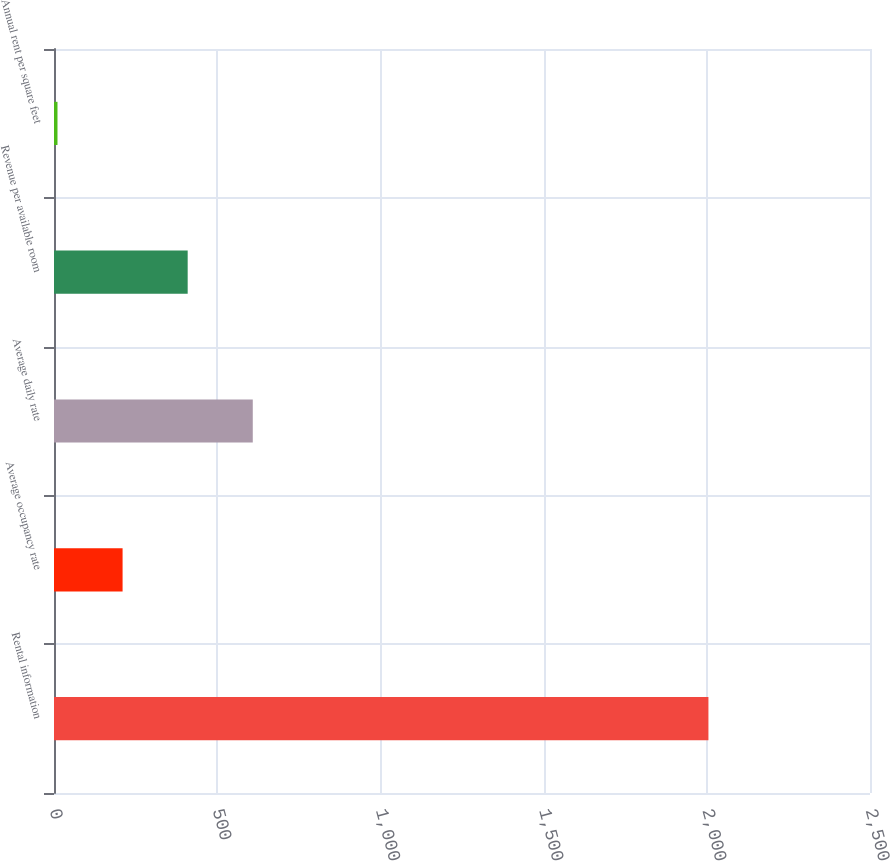<chart> <loc_0><loc_0><loc_500><loc_500><bar_chart><fcel>Rental information<fcel>Average occupancy rate<fcel>Average daily rate<fcel>Revenue per available room<fcel>Annual rent per square feet<nl><fcel>2005<fcel>210.13<fcel>608.99<fcel>409.56<fcel>10.7<nl></chart> 